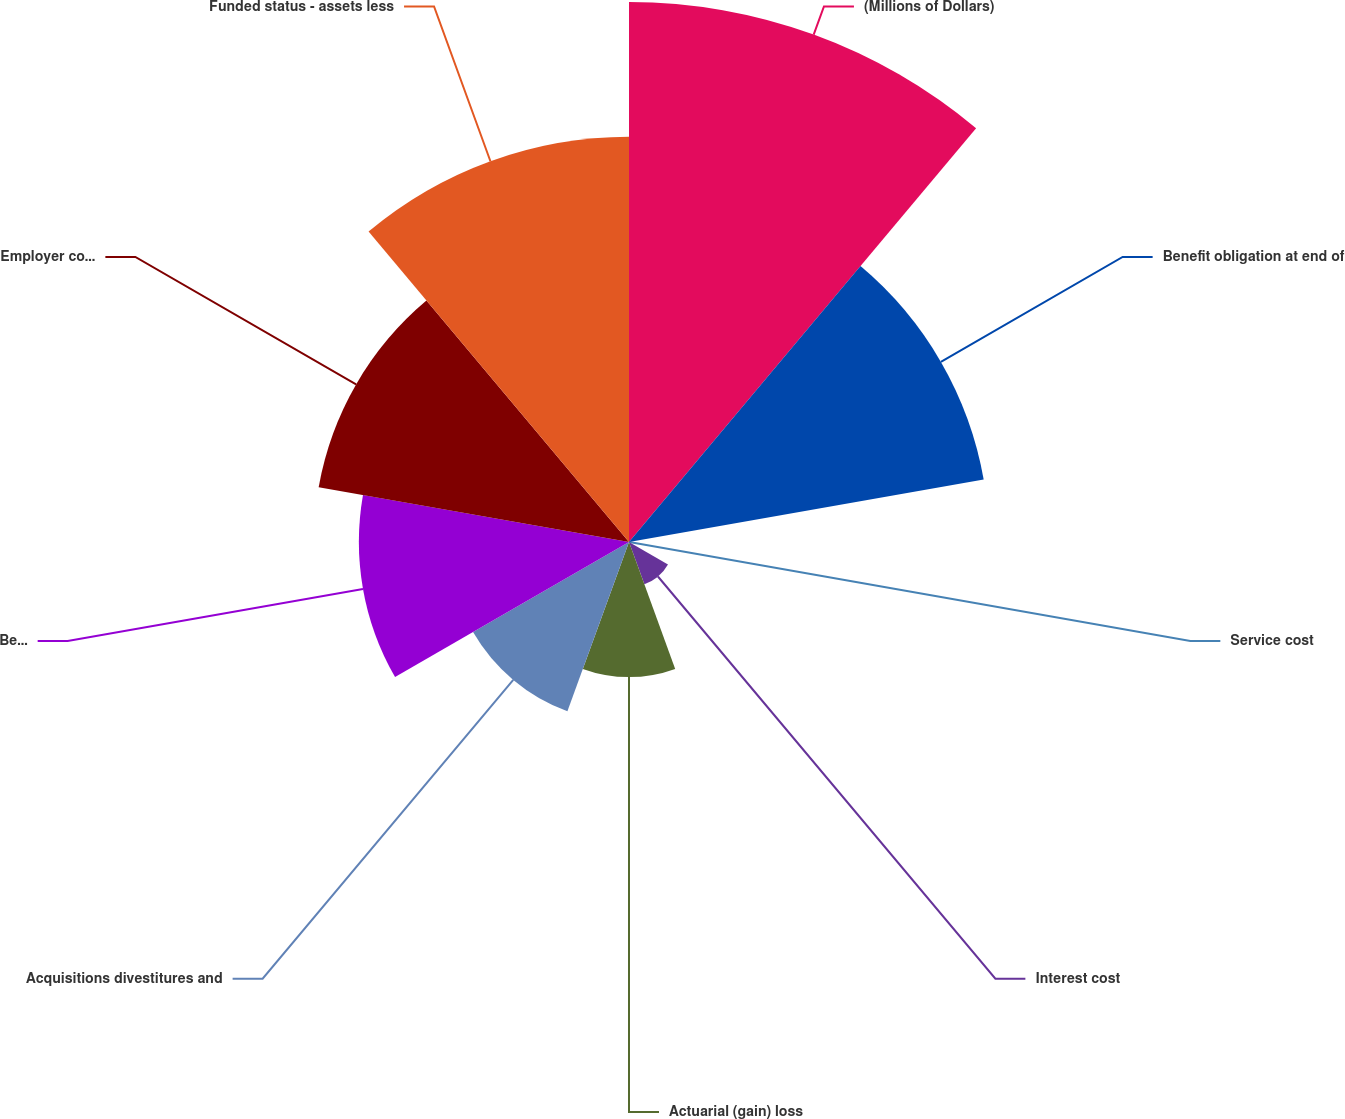Convert chart to OTSL. <chart><loc_0><loc_0><loc_500><loc_500><pie_chart><fcel>(Millions of Dollars)<fcel>Benefit obligation at end of<fcel>Service cost<fcel>Interest cost<fcel>Actuarial (gain) loss<fcel>Acquisitions divestitures and<fcel>Benefits paid<fcel>Employer contributions<fcel>Funded status - assets less<nl><fcel>23.99%<fcel>16.0%<fcel>0.01%<fcel>2.0%<fcel>6.0%<fcel>8.0%<fcel>12.0%<fcel>14.0%<fcel>18.0%<nl></chart> 